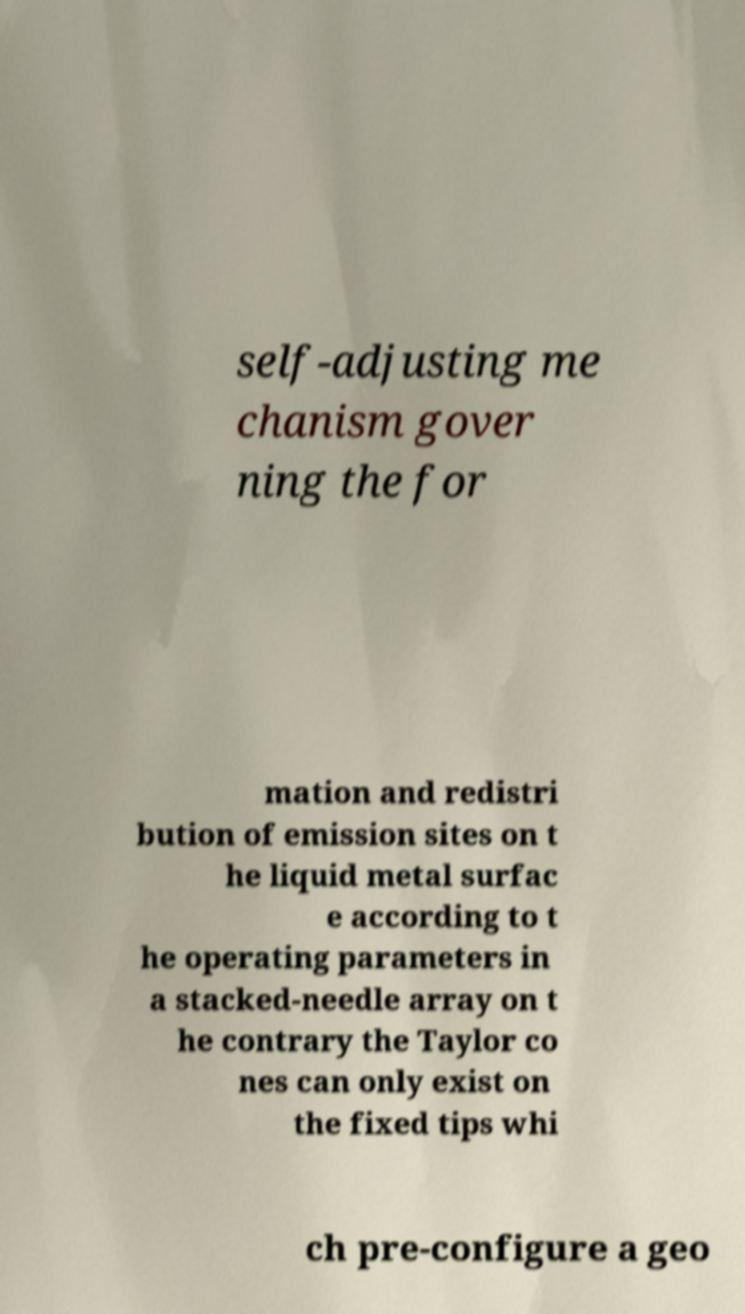Could you extract and type out the text from this image? self-adjusting me chanism gover ning the for mation and redistri bution of emission sites on t he liquid metal surfac e according to t he operating parameters in a stacked-needle array on t he contrary the Taylor co nes can only exist on the fixed tips whi ch pre-configure a geo 